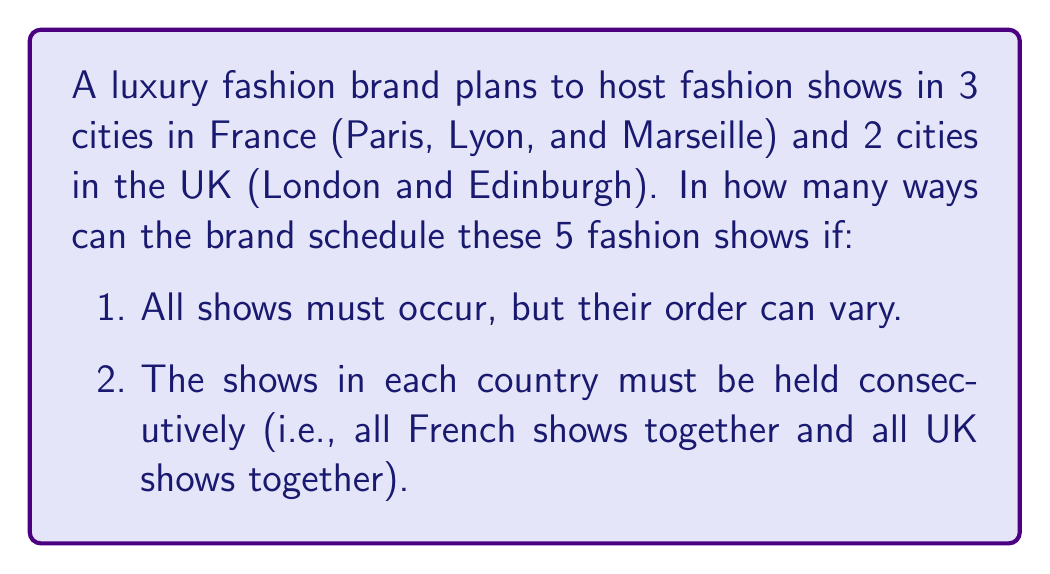Can you solve this math problem? Let's approach this step-by-step:

1) First, we need to determine how many ways we can arrange the two countries. This is a simple permutation of 2 items, which is $2! = 2$.

2) Next, for France, we need to arrange 3 cities. This is a permutation of 3 items, which is $3! = 6$.

3) For the UK, we need to arrange 2 cities. This is a permutation of 2 items, which is $2! = 2$.

4) According to the Multiplication Principle, if we have $m$ ways of doing something and $n$ ways of doing another thing, then there are $m \times n$ ways of doing both things.

5) Therefore, the total number of ways to schedule the fashion shows is:

   $$(2!) \times (3!) \times (2!) = 2 \times 6 \times 2 = 24$$

This calculation considers all possible orders of countries, all possible orders of French cities, and all possible orders of UK cities, while keeping each country's shows consecutive.
Answer: 24 ways 